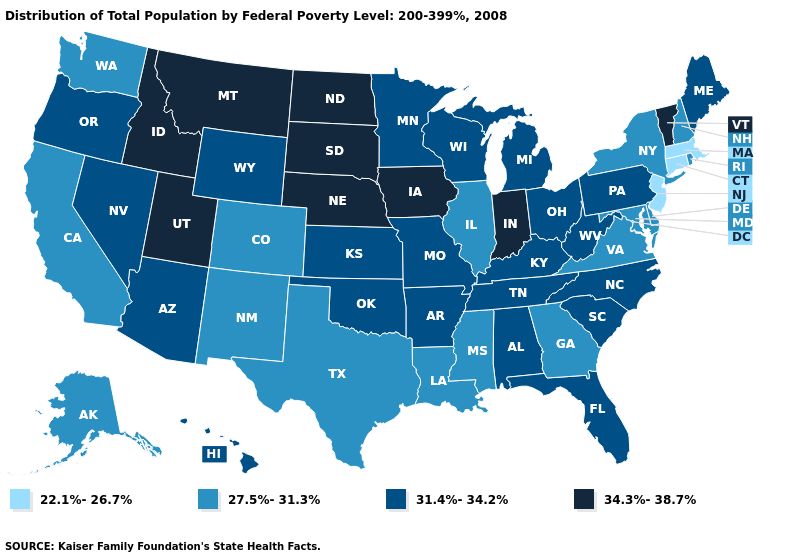Among the states that border Florida , does Georgia have the lowest value?
Keep it brief. Yes. What is the value of Maine?
Keep it brief. 31.4%-34.2%. What is the lowest value in the USA?
Quick response, please. 22.1%-26.7%. Name the states that have a value in the range 27.5%-31.3%?
Write a very short answer. Alaska, California, Colorado, Delaware, Georgia, Illinois, Louisiana, Maryland, Mississippi, New Hampshire, New Mexico, New York, Rhode Island, Texas, Virginia, Washington. Name the states that have a value in the range 34.3%-38.7%?
Be succinct. Idaho, Indiana, Iowa, Montana, Nebraska, North Dakota, South Dakota, Utah, Vermont. Does North Dakota have a higher value than Nebraska?
Answer briefly. No. Name the states that have a value in the range 34.3%-38.7%?
Keep it brief. Idaho, Indiana, Iowa, Montana, Nebraska, North Dakota, South Dakota, Utah, Vermont. What is the lowest value in the USA?
Quick response, please. 22.1%-26.7%. What is the lowest value in the USA?
Write a very short answer. 22.1%-26.7%. What is the value of New Jersey?
Write a very short answer. 22.1%-26.7%. What is the value of Connecticut?
Quick response, please. 22.1%-26.7%. Among the states that border Wisconsin , does Michigan have the lowest value?
Be succinct. No. Among the states that border New York , which have the highest value?
Quick response, please. Vermont. Which states have the lowest value in the USA?
Answer briefly. Connecticut, Massachusetts, New Jersey. What is the highest value in the West ?
Answer briefly. 34.3%-38.7%. 